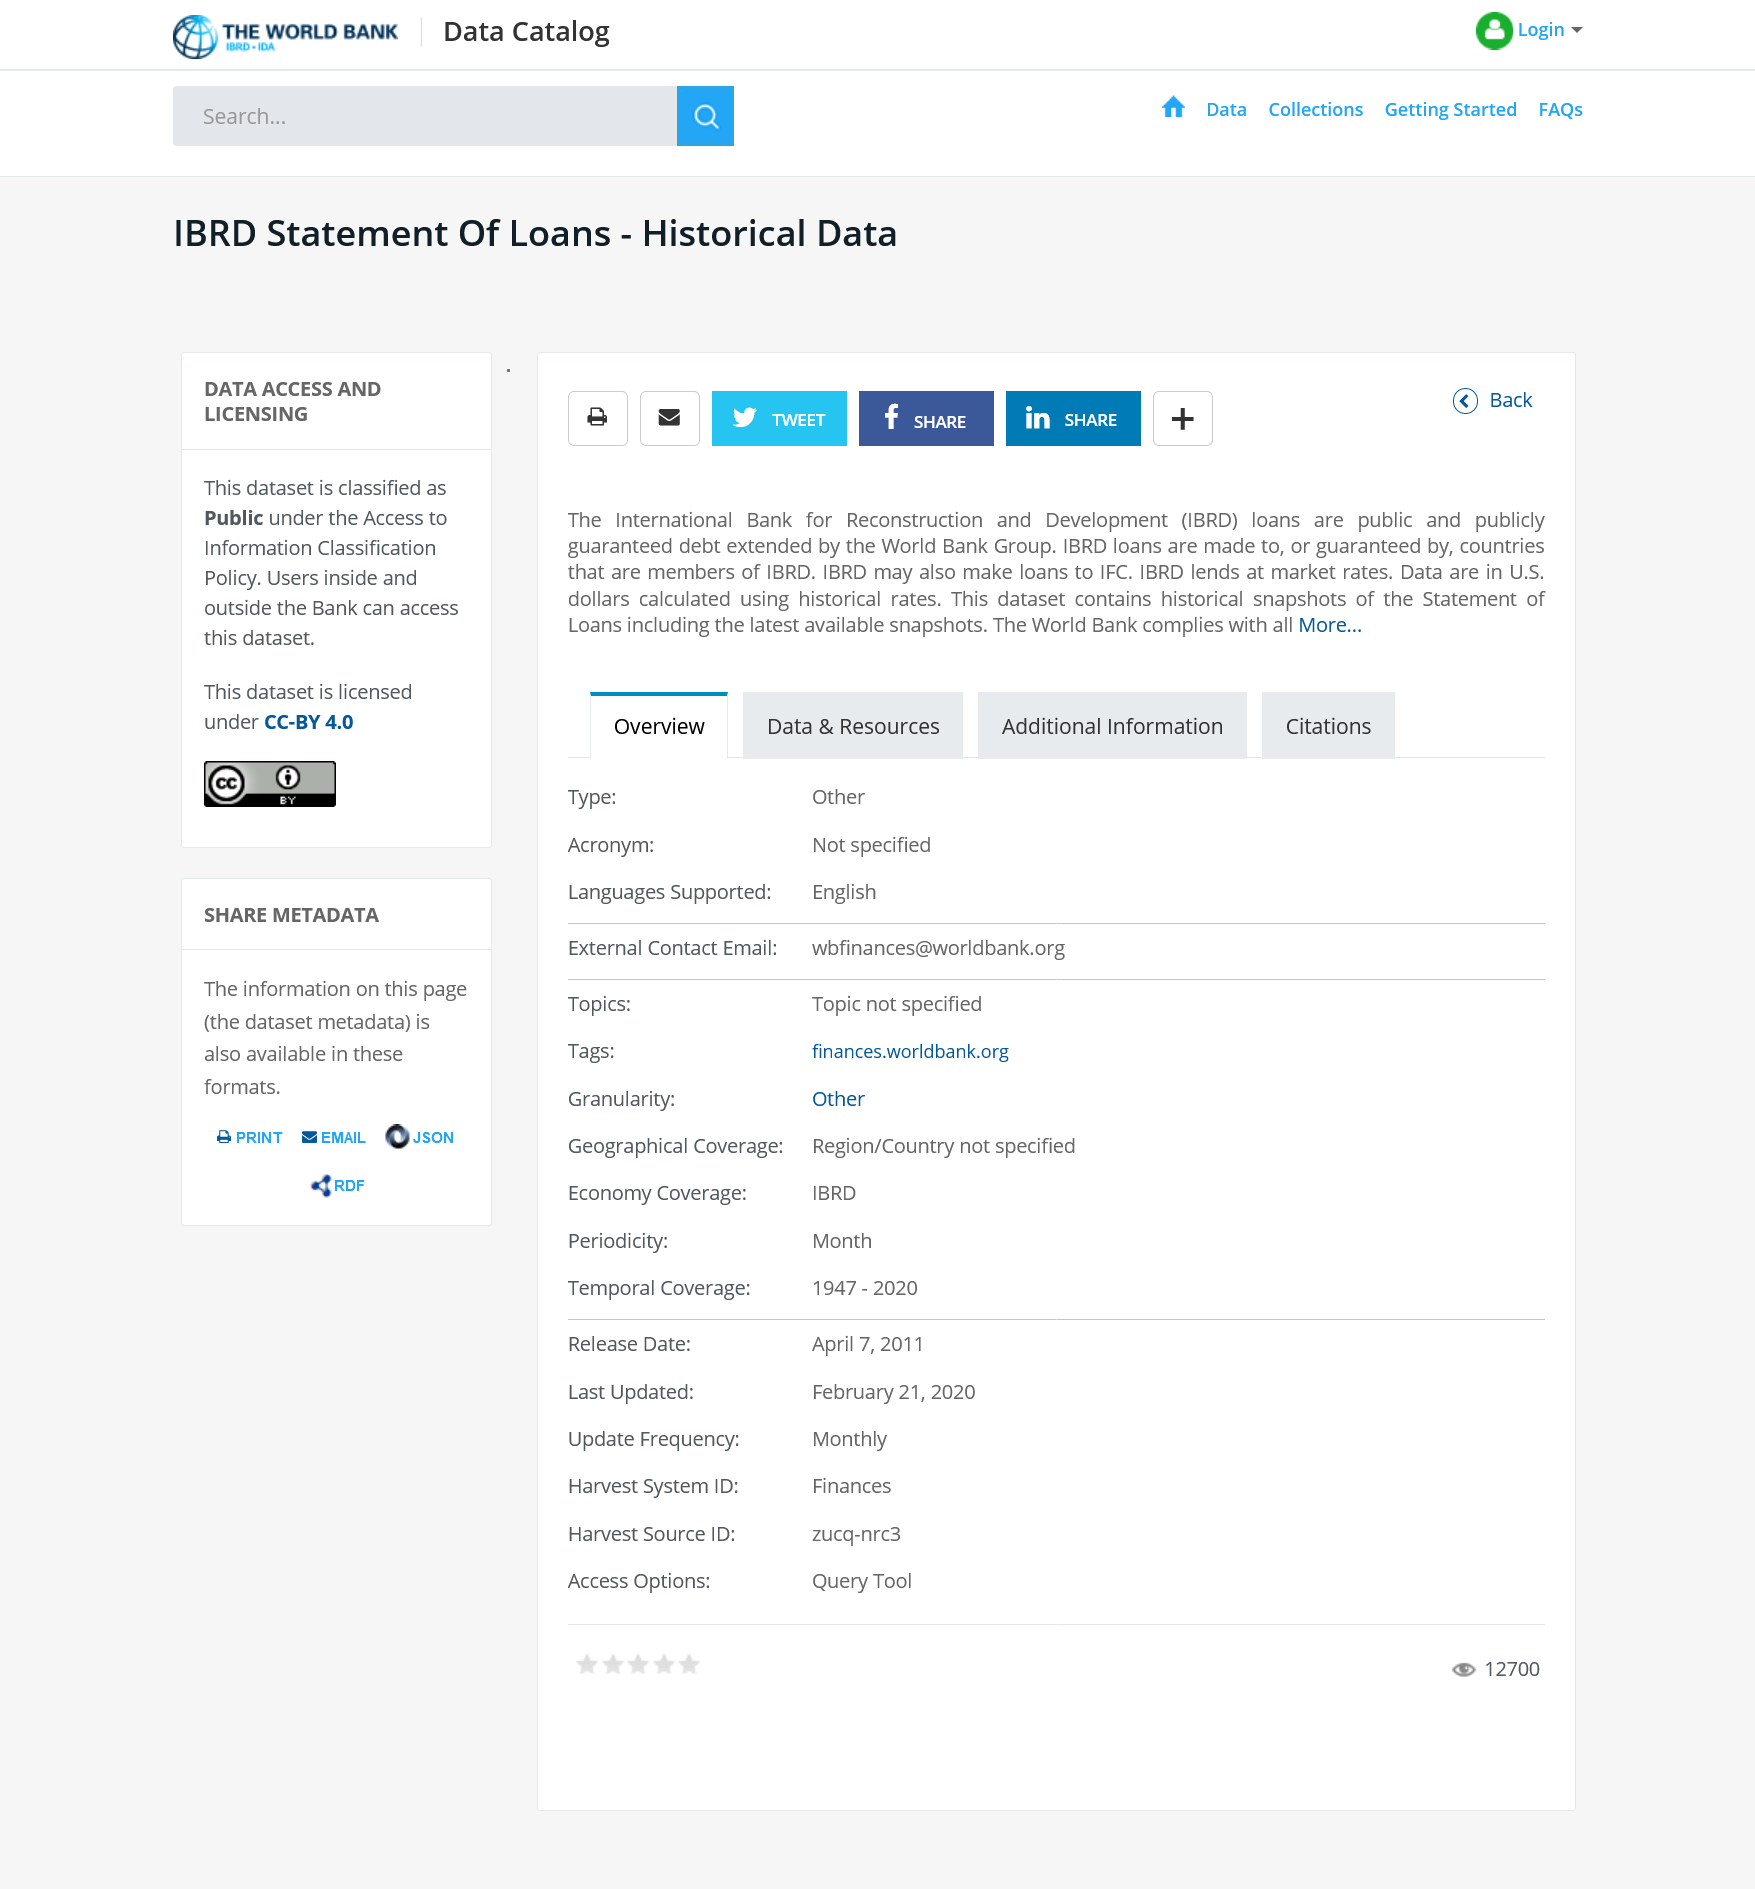Outline some significant characteristics in this image. Yes, IBRD lends at market rates. It is possible to share this on Facebook. This content has public data access, indicating that it can be accessed and viewed by anyone. 